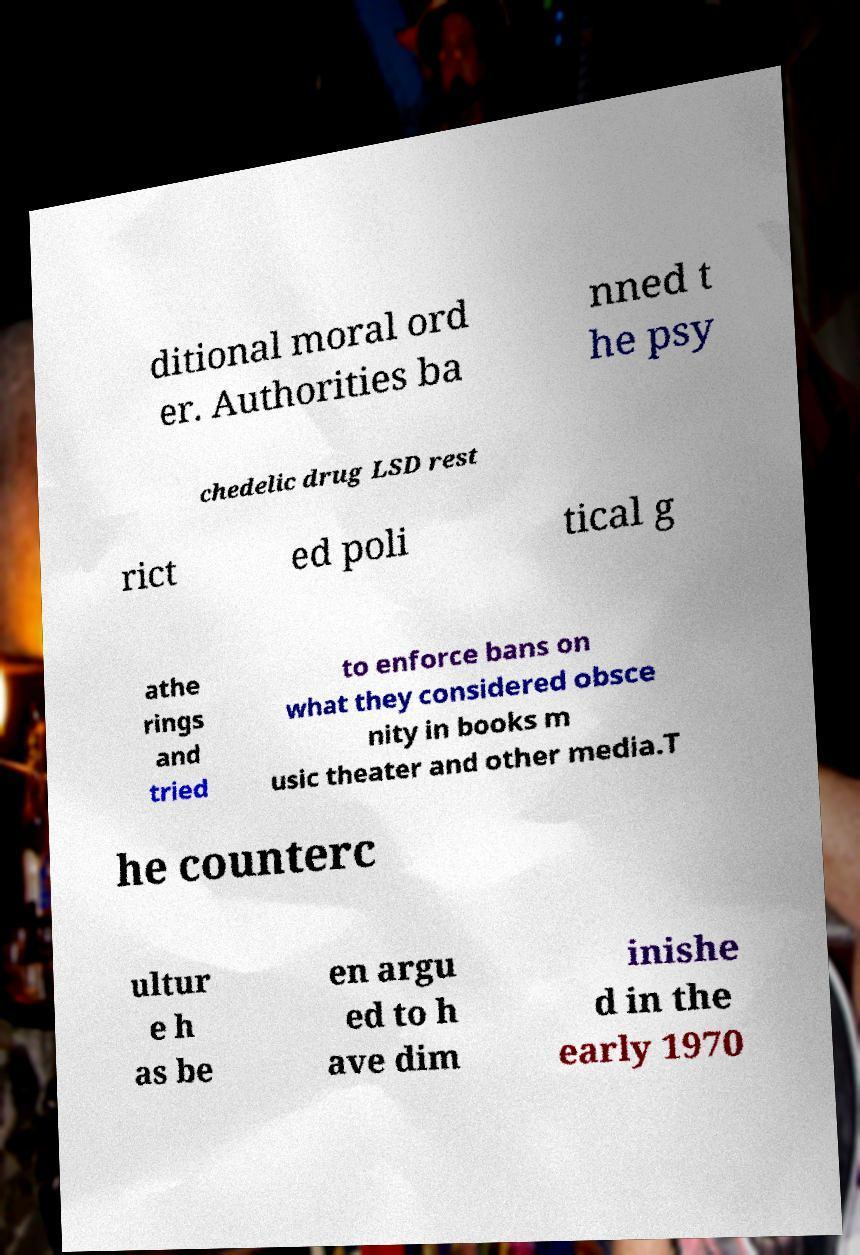What messages or text are displayed in this image? I need them in a readable, typed format. ditional moral ord er. Authorities ba nned t he psy chedelic drug LSD rest rict ed poli tical g athe rings and tried to enforce bans on what they considered obsce nity in books m usic theater and other media.T he counterc ultur e h as be en argu ed to h ave dim inishe d in the early 1970 